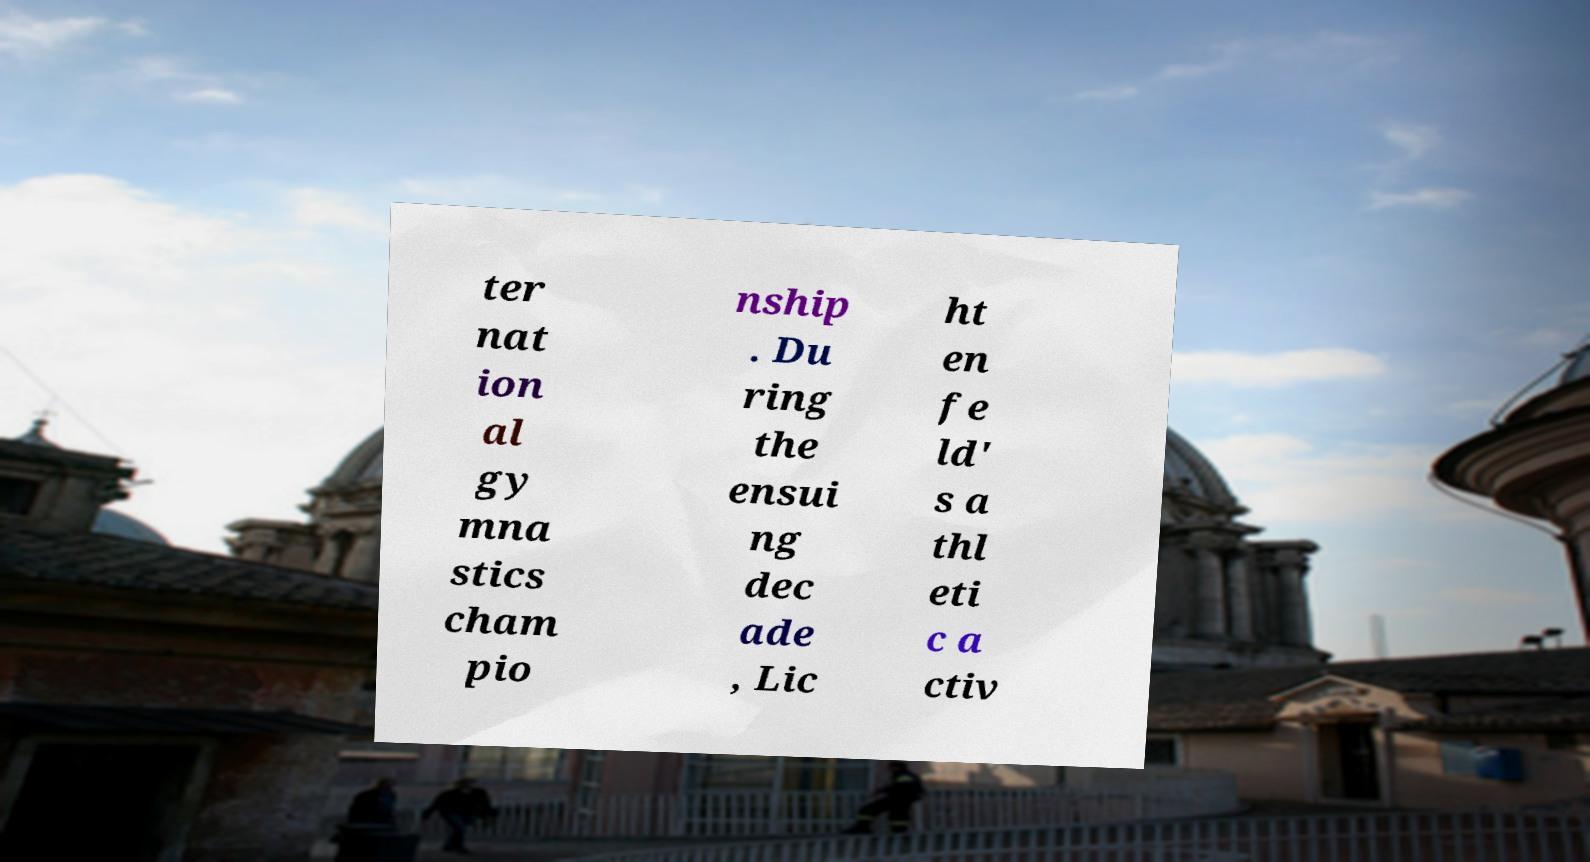Can you accurately transcribe the text from the provided image for me? ter nat ion al gy mna stics cham pio nship . Du ring the ensui ng dec ade , Lic ht en fe ld' s a thl eti c a ctiv 